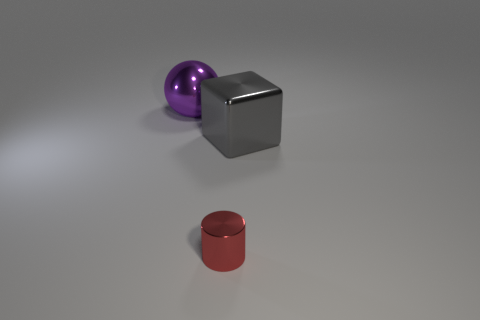Add 1 red metallic things. How many objects exist? 4 Subtract all blocks. How many objects are left? 2 Add 1 small red things. How many small red things exist? 2 Subtract 0 green balls. How many objects are left? 3 Subtract all red metallic cylinders. Subtract all balls. How many objects are left? 1 Add 3 shiny cubes. How many shiny cubes are left? 4 